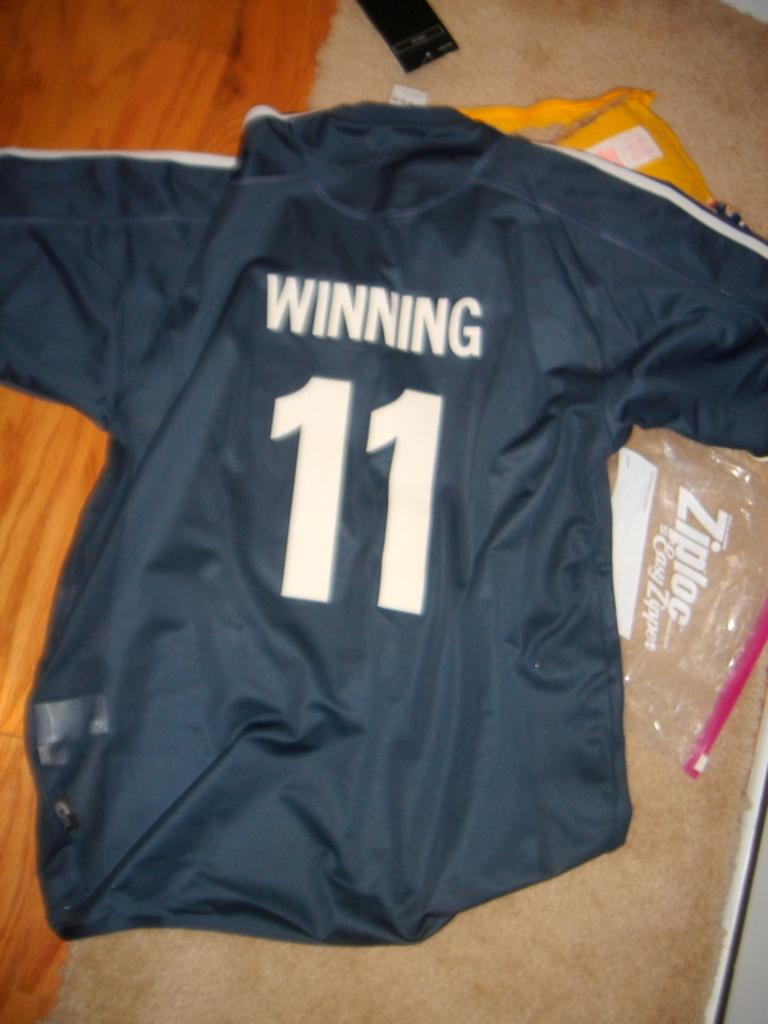<image>
Write a terse but informative summary of the picture. On the floor is a jersey that says WINNING and has the number 11. 